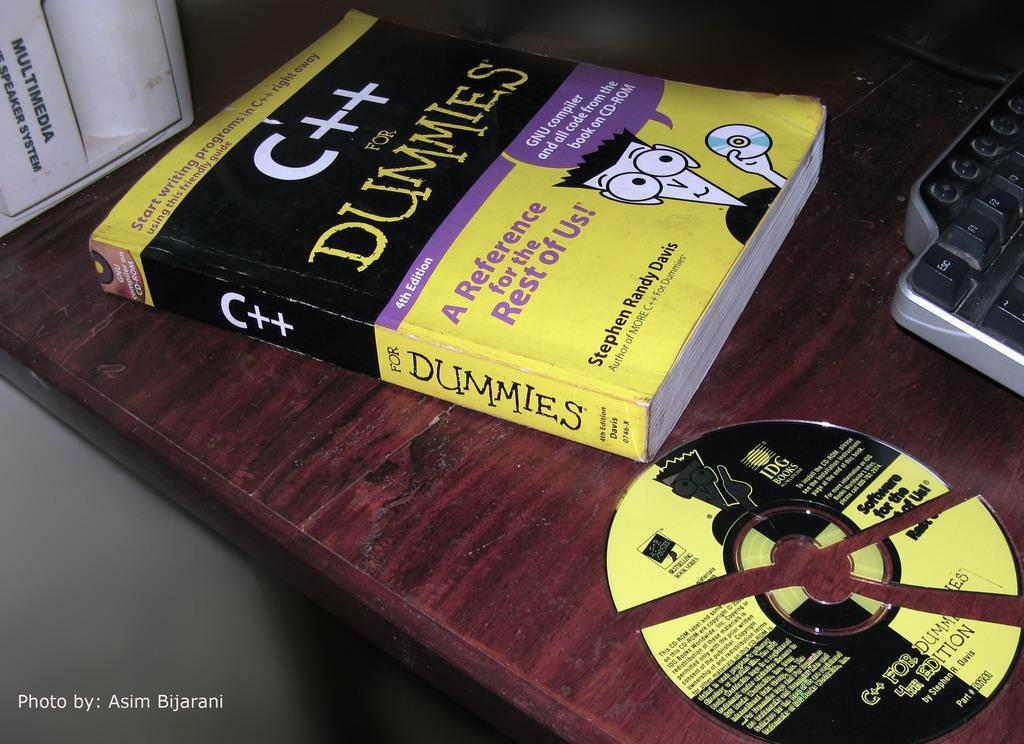<image>
Relay a brief, clear account of the picture shown. A book called C++ for Dummies sits next to a broken CD 